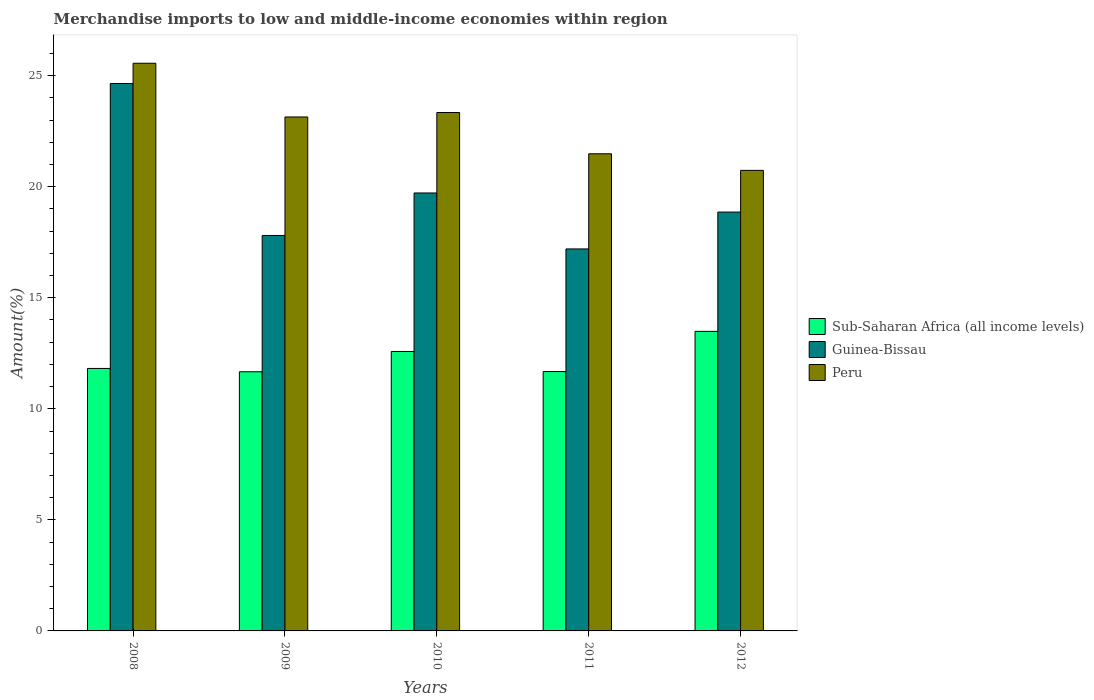Are the number of bars on each tick of the X-axis equal?
Your answer should be very brief. Yes. How many bars are there on the 3rd tick from the right?
Your answer should be compact. 3. What is the percentage of amount earned from merchandise imports in Peru in 2008?
Provide a short and direct response. 25.56. Across all years, what is the maximum percentage of amount earned from merchandise imports in Sub-Saharan Africa (all income levels)?
Offer a terse response. 13.49. Across all years, what is the minimum percentage of amount earned from merchandise imports in Sub-Saharan Africa (all income levels)?
Keep it short and to the point. 11.67. In which year was the percentage of amount earned from merchandise imports in Peru maximum?
Offer a terse response. 2008. In which year was the percentage of amount earned from merchandise imports in Guinea-Bissau minimum?
Your answer should be compact. 2011. What is the total percentage of amount earned from merchandise imports in Peru in the graph?
Provide a short and direct response. 114.26. What is the difference between the percentage of amount earned from merchandise imports in Peru in 2008 and that in 2009?
Ensure brevity in your answer.  2.42. What is the difference between the percentage of amount earned from merchandise imports in Sub-Saharan Africa (all income levels) in 2009 and the percentage of amount earned from merchandise imports in Peru in 2012?
Offer a very short reply. -9.07. What is the average percentage of amount earned from merchandise imports in Guinea-Bissau per year?
Make the answer very short. 19.64. In the year 2012, what is the difference between the percentage of amount earned from merchandise imports in Guinea-Bissau and percentage of amount earned from merchandise imports in Sub-Saharan Africa (all income levels)?
Give a very brief answer. 5.37. What is the ratio of the percentage of amount earned from merchandise imports in Guinea-Bissau in 2009 to that in 2012?
Your answer should be very brief. 0.94. Is the difference between the percentage of amount earned from merchandise imports in Guinea-Bissau in 2008 and 2012 greater than the difference between the percentage of amount earned from merchandise imports in Sub-Saharan Africa (all income levels) in 2008 and 2012?
Provide a succinct answer. Yes. What is the difference between the highest and the second highest percentage of amount earned from merchandise imports in Sub-Saharan Africa (all income levels)?
Ensure brevity in your answer.  0.91. What is the difference between the highest and the lowest percentage of amount earned from merchandise imports in Guinea-Bissau?
Your answer should be very brief. 7.45. In how many years, is the percentage of amount earned from merchandise imports in Guinea-Bissau greater than the average percentage of amount earned from merchandise imports in Guinea-Bissau taken over all years?
Provide a succinct answer. 2. What does the 1st bar from the left in 2010 represents?
Your answer should be very brief. Sub-Saharan Africa (all income levels). What does the 1st bar from the right in 2009 represents?
Offer a very short reply. Peru. Is it the case that in every year, the sum of the percentage of amount earned from merchandise imports in Sub-Saharan Africa (all income levels) and percentage of amount earned from merchandise imports in Guinea-Bissau is greater than the percentage of amount earned from merchandise imports in Peru?
Offer a very short reply. Yes. How many bars are there?
Your response must be concise. 15. How many years are there in the graph?
Offer a terse response. 5. Are the values on the major ticks of Y-axis written in scientific E-notation?
Provide a short and direct response. No. Does the graph contain grids?
Your answer should be compact. No. How many legend labels are there?
Your answer should be compact. 3. How are the legend labels stacked?
Your answer should be compact. Vertical. What is the title of the graph?
Your response must be concise. Merchandise imports to low and middle-income economies within region. Does "Trinidad and Tobago" appear as one of the legend labels in the graph?
Your answer should be very brief. No. What is the label or title of the Y-axis?
Your answer should be very brief. Amount(%). What is the Amount(%) of Sub-Saharan Africa (all income levels) in 2008?
Offer a terse response. 11.82. What is the Amount(%) in Guinea-Bissau in 2008?
Your answer should be compact. 24.65. What is the Amount(%) in Peru in 2008?
Ensure brevity in your answer.  25.56. What is the Amount(%) in Sub-Saharan Africa (all income levels) in 2009?
Offer a terse response. 11.67. What is the Amount(%) in Guinea-Bissau in 2009?
Your answer should be compact. 17.8. What is the Amount(%) of Peru in 2009?
Offer a terse response. 23.14. What is the Amount(%) in Sub-Saharan Africa (all income levels) in 2010?
Your answer should be compact. 12.58. What is the Amount(%) in Guinea-Bissau in 2010?
Your answer should be compact. 19.72. What is the Amount(%) in Peru in 2010?
Your response must be concise. 23.34. What is the Amount(%) in Sub-Saharan Africa (all income levels) in 2011?
Provide a short and direct response. 11.68. What is the Amount(%) in Guinea-Bissau in 2011?
Your answer should be very brief. 17.2. What is the Amount(%) in Peru in 2011?
Offer a terse response. 21.48. What is the Amount(%) of Sub-Saharan Africa (all income levels) in 2012?
Your response must be concise. 13.49. What is the Amount(%) in Guinea-Bissau in 2012?
Offer a very short reply. 18.86. What is the Amount(%) in Peru in 2012?
Your answer should be compact. 20.74. Across all years, what is the maximum Amount(%) in Sub-Saharan Africa (all income levels)?
Ensure brevity in your answer.  13.49. Across all years, what is the maximum Amount(%) of Guinea-Bissau?
Give a very brief answer. 24.65. Across all years, what is the maximum Amount(%) in Peru?
Your answer should be very brief. 25.56. Across all years, what is the minimum Amount(%) of Sub-Saharan Africa (all income levels)?
Your answer should be very brief. 11.67. Across all years, what is the minimum Amount(%) of Guinea-Bissau?
Make the answer very short. 17.2. Across all years, what is the minimum Amount(%) in Peru?
Offer a terse response. 20.74. What is the total Amount(%) in Sub-Saharan Africa (all income levels) in the graph?
Ensure brevity in your answer.  61.23. What is the total Amount(%) in Guinea-Bissau in the graph?
Make the answer very short. 98.22. What is the total Amount(%) of Peru in the graph?
Give a very brief answer. 114.26. What is the difference between the Amount(%) of Sub-Saharan Africa (all income levels) in 2008 and that in 2009?
Your answer should be very brief. 0.15. What is the difference between the Amount(%) of Guinea-Bissau in 2008 and that in 2009?
Ensure brevity in your answer.  6.84. What is the difference between the Amount(%) of Peru in 2008 and that in 2009?
Your answer should be very brief. 2.42. What is the difference between the Amount(%) of Sub-Saharan Africa (all income levels) in 2008 and that in 2010?
Offer a very short reply. -0.76. What is the difference between the Amount(%) of Guinea-Bissau in 2008 and that in 2010?
Make the answer very short. 4.93. What is the difference between the Amount(%) of Peru in 2008 and that in 2010?
Provide a succinct answer. 2.22. What is the difference between the Amount(%) in Sub-Saharan Africa (all income levels) in 2008 and that in 2011?
Provide a short and direct response. 0.14. What is the difference between the Amount(%) in Guinea-Bissau in 2008 and that in 2011?
Your answer should be compact. 7.45. What is the difference between the Amount(%) in Peru in 2008 and that in 2011?
Your answer should be compact. 4.08. What is the difference between the Amount(%) of Sub-Saharan Africa (all income levels) in 2008 and that in 2012?
Provide a succinct answer. -1.67. What is the difference between the Amount(%) in Guinea-Bissau in 2008 and that in 2012?
Offer a very short reply. 5.79. What is the difference between the Amount(%) of Peru in 2008 and that in 2012?
Offer a terse response. 4.82. What is the difference between the Amount(%) of Sub-Saharan Africa (all income levels) in 2009 and that in 2010?
Offer a very short reply. -0.91. What is the difference between the Amount(%) of Guinea-Bissau in 2009 and that in 2010?
Your answer should be very brief. -1.91. What is the difference between the Amount(%) in Peru in 2009 and that in 2010?
Ensure brevity in your answer.  -0.2. What is the difference between the Amount(%) in Sub-Saharan Africa (all income levels) in 2009 and that in 2011?
Provide a short and direct response. -0.01. What is the difference between the Amount(%) of Guinea-Bissau in 2009 and that in 2011?
Provide a short and direct response. 0.61. What is the difference between the Amount(%) of Peru in 2009 and that in 2011?
Make the answer very short. 1.66. What is the difference between the Amount(%) in Sub-Saharan Africa (all income levels) in 2009 and that in 2012?
Give a very brief answer. -1.82. What is the difference between the Amount(%) of Guinea-Bissau in 2009 and that in 2012?
Give a very brief answer. -1.05. What is the difference between the Amount(%) of Peru in 2009 and that in 2012?
Your answer should be compact. 2.4. What is the difference between the Amount(%) in Sub-Saharan Africa (all income levels) in 2010 and that in 2011?
Offer a terse response. 0.9. What is the difference between the Amount(%) of Guinea-Bissau in 2010 and that in 2011?
Make the answer very short. 2.52. What is the difference between the Amount(%) of Peru in 2010 and that in 2011?
Provide a short and direct response. 1.86. What is the difference between the Amount(%) in Sub-Saharan Africa (all income levels) in 2010 and that in 2012?
Your response must be concise. -0.91. What is the difference between the Amount(%) of Guinea-Bissau in 2010 and that in 2012?
Provide a short and direct response. 0.86. What is the difference between the Amount(%) in Peru in 2010 and that in 2012?
Make the answer very short. 2.61. What is the difference between the Amount(%) in Sub-Saharan Africa (all income levels) in 2011 and that in 2012?
Give a very brief answer. -1.81. What is the difference between the Amount(%) in Guinea-Bissau in 2011 and that in 2012?
Offer a very short reply. -1.66. What is the difference between the Amount(%) in Peru in 2011 and that in 2012?
Ensure brevity in your answer.  0.75. What is the difference between the Amount(%) of Sub-Saharan Africa (all income levels) in 2008 and the Amount(%) of Guinea-Bissau in 2009?
Ensure brevity in your answer.  -5.99. What is the difference between the Amount(%) in Sub-Saharan Africa (all income levels) in 2008 and the Amount(%) in Peru in 2009?
Your answer should be compact. -11.32. What is the difference between the Amount(%) of Guinea-Bissau in 2008 and the Amount(%) of Peru in 2009?
Your response must be concise. 1.51. What is the difference between the Amount(%) in Sub-Saharan Africa (all income levels) in 2008 and the Amount(%) in Guinea-Bissau in 2010?
Provide a succinct answer. -7.9. What is the difference between the Amount(%) of Sub-Saharan Africa (all income levels) in 2008 and the Amount(%) of Peru in 2010?
Your answer should be very brief. -11.52. What is the difference between the Amount(%) of Guinea-Bissau in 2008 and the Amount(%) of Peru in 2010?
Offer a very short reply. 1.31. What is the difference between the Amount(%) in Sub-Saharan Africa (all income levels) in 2008 and the Amount(%) in Guinea-Bissau in 2011?
Provide a succinct answer. -5.38. What is the difference between the Amount(%) of Sub-Saharan Africa (all income levels) in 2008 and the Amount(%) of Peru in 2011?
Provide a short and direct response. -9.67. What is the difference between the Amount(%) in Guinea-Bissau in 2008 and the Amount(%) in Peru in 2011?
Your answer should be very brief. 3.16. What is the difference between the Amount(%) in Sub-Saharan Africa (all income levels) in 2008 and the Amount(%) in Guinea-Bissau in 2012?
Your answer should be very brief. -7.04. What is the difference between the Amount(%) in Sub-Saharan Africa (all income levels) in 2008 and the Amount(%) in Peru in 2012?
Your answer should be very brief. -8.92. What is the difference between the Amount(%) of Guinea-Bissau in 2008 and the Amount(%) of Peru in 2012?
Your answer should be compact. 3.91. What is the difference between the Amount(%) of Sub-Saharan Africa (all income levels) in 2009 and the Amount(%) of Guinea-Bissau in 2010?
Ensure brevity in your answer.  -8.05. What is the difference between the Amount(%) in Sub-Saharan Africa (all income levels) in 2009 and the Amount(%) in Peru in 2010?
Provide a short and direct response. -11.67. What is the difference between the Amount(%) in Guinea-Bissau in 2009 and the Amount(%) in Peru in 2010?
Your answer should be compact. -5.54. What is the difference between the Amount(%) of Sub-Saharan Africa (all income levels) in 2009 and the Amount(%) of Guinea-Bissau in 2011?
Make the answer very short. -5.53. What is the difference between the Amount(%) of Sub-Saharan Africa (all income levels) in 2009 and the Amount(%) of Peru in 2011?
Provide a succinct answer. -9.81. What is the difference between the Amount(%) in Guinea-Bissau in 2009 and the Amount(%) in Peru in 2011?
Your answer should be compact. -3.68. What is the difference between the Amount(%) in Sub-Saharan Africa (all income levels) in 2009 and the Amount(%) in Guinea-Bissau in 2012?
Your answer should be compact. -7.19. What is the difference between the Amount(%) in Sub-Saharan Africa (all income levels) in 2009 and the Amount(%) in Peru in 2012?
Make the answer very short. -9.07. What is the difference between the Amount(%) in Guinea-Bissau in 2009 and the Amount(%) in Peru in 2012?
Give a very brief answer. -2.93. What is the difference between the Amount(%) in Sub-Saharan Africa (all income levels) in 2010 and the Amount(%) in Guinea-Bissau in 2011?
Keep it short and to the point. -4.62. What is the difference between the Amount(%) of Sub-Saharan Africa (all income levels) in 2010 and the Amount(%) of Peru in 2011?
Keep it short and to the point. -8.9. What is the difference between the Amount(%) in Guinea-Bissau in 2010 and the Amount(%) in Peru in 2011?
Provide a succinct answer. -1.76. What is the difference between the Amount(%) of Sub-Saharan Africa (all income levels) in 2010 and the Amount(%) of Guinea-Bissau in 2012?
Make the answer very short. -6.28. What is the difference between the Amount(%) in Sub-Saharan Africa (all income levels) in 2010 and the Amount(%) in Peru in 2012?
Provide a succinct answer. -8.15. What is the difference between the Amount(%) in Guinea-Bissau in 2010 and the Amount(%) in Peru in 2012?
Offer a terse response. -1.02. What is the difference between the Amount(%) in Sub-Saharan Africa (all income levels) in 2011 and the Amount(%) in Guinea-Bissau in 2012?
Ensure brevity in your answer.  -7.18. What is the difference between the Amount(%) in Sub-Saharan Africa (all income levels) in 2011 and the Amount(%) in Peru in 2012?
Provide a short and direct response. -9.06. What is the difference between the Amount(%) in Guinea-Bissau in 2011 and the Amount(%) in Peru in 2012?
Offer a very short reply. -3.54. What is the average Amount(%) in Sub-Saharan Africa (all income levels) per year?
Provide a short and direct response. 12.25. What is the average Amount(%) of Guinea-Bissau per year?
Your answer should be compact. 19.64. What is the average Amount(%) in Peru per year?
Your answer should be compact. 22.85. In the year 2008, what is the difference between the Amount(%) of Sub-Saharan Africa (all income levels) and Amount(%) of Guinea-Bissau?
Make the answer very short. -12.83. In the year 2008, what is the difference between the Amount(%) of Sub-Saharan Africa (all income levels) and Amount(%) of Peru?
Ensure brevity in your answer.  -13.74. In the year 2008, what is the difference between the Amount(%) in Guinea-Bissau and Amount(%) in Peru?
Your response must be concise. -0.91. In the year 2009, what is the difference between the Amount(%) of Sub-Saharan Africa (all income levels) and Amount(%) of Guinea-Bissau?
Make the answer very short. -6.14. In the year 2009, what is the difference between the Amount(%) in Sub-Saharan Africa (all income levels) and Amount(%) in Peru?
Your answer should be compact. -11.47. In the year 2009, what is the difference between the Amount(%) in Guinea-Bissau and Amount(%) in Peru?
Give a very brief answer. -5.34. In the year 2010, what is the difference between the Amount(%) in Sub-Saharan Africa (all income levels) and Amount(%) in Guinea-Bissau?
Keep it short and to the point. -7.14. In the year 2010, what is the difference between the Amount(%) in Sub-Saharan Africa (all income levels) and Amount(%) in Peru?
Offer a terse response. -10.76. In the year 2010, what is the difference between the Amount(%) of Guinea-Bissau and Amount(%) of Peru?
Give a very brief answer. -3.62. In the year 2011, what is the difference between the Amount(%) of Sub-Saharan Africa (all income levels) and Amount(%) of Guinea-Bissau?
Offer a terse response. -5.52. In the year 2011, what is the difference between the Amount(%) in Sub-Saharan Africa (all income levels) and Amount(%) in Peru?
Keep it short and to the point. -9.81. In the year 2011, what is the difference between the Amount(%) of Guinea-Bissau and Amount(%) of Peru?
Provide a succinct answer. -4.28. In the year 2012, what is the difference between the Amount(%) in Sub-Saharan Africa (all income levels) and Amount(%) in Guinea-Bissau?
Offer a very short reply. -5.37. In the year 2012, what is the difference between the Amount(%) in Sub-Saharan Africa (all income levels) and Amount(%) in Peru?
Offer a very short reply. -7.25. In the year 2012, what is the difference between the Amount(%) of Guinea-Bissau and Amount(%) of Peru?
Offer a very short reply. -1.88. What is the ratio of the Amount(%) in Sub-Saharan Africa (all income levels) in 2008 to that in 2009?
Ensure brevity in your answer.  1.01. What is the ratio of the Amount(%) in Guinea-Bissau in 2008 to that in 2009?
Make the answer very short. 1.38. What is the ratio of the Amount(%) in Peru in 2008 to that in 2009?
Your answer should be very brief. 1.1. What is the ratio of the Amount(%) in Sub-Saharan Africa (all income levels) in 2008 to that in 2010?
Your answer should be compact. 0.94. What is the ratio of the Amount(%) in Guinea-Bissau in 2008 to that in 2010?
Keep it short and to the point. 1.25. What is the ratio of the Amount(%) of Peru in 2008 to that in 2010?
Keep it short and to the point. 1.09. What is the ratio of the Amount(%) in Guinea-Bissau in 2008 to that in 2011?
Offer a terse response. 1.43. What is the ratio of the Amount(%) in Peru in 2008 to that in 2011?
Your response must be concise. 1.19. What is the ratio of the Amount(%) of Sub-Saharan Africa (all income levels) in 2008 to that in 2012?
Your answer should be compact. 0.88. What is the ratio of the Amount(%) in Guinea-Bissau in 2008 to that in 2012?
Ensure brevity in your answer.  1.31. What is the ratio of the Amount(%) in Peru in 2008 to that in 2012?
Offer a terse response. 1.23. What is the ratio of the Amount(%) in Sub-Saharan Africa (all income levels) in 2009 to that in 2010?
Your response must be concise. 0.93. What is the ratio of the Amount(%) in Guinea-Bissau in 2009 to that in 2010?
Your answer should be very brief. 0.9. What is the ratio of the Amount(%) in Sub-Saharan Africa (all income levels) in 2009 to that in 2011?
Ensure brevity in your answer.  1. What is the ratio of the Amount(%) in Guinea-Bissau in 2009 to that in 2011?
Your answer should be compact. 1.04. What is the ratio of the Amount(%) in Peru in 2009 to that in 2011?
Offer a terse response. 1.08. What is the ratio of the Amount(%) of Sub-Saharan Africa (all income levels) in 2009 to that in 2012?
Give a very brief answer. 0.87. What is the ratio of the Amount(%) of Guinea-Bissau in 2009 to that in 2012?
Your answer should be compact. 0.94. What is the ratio of the Amount(%) in Peru in 2009 to that in 2012?
Provide a succinct answer. 1.12. What is the ratio of the Amount(%) of Sub-Saharan Africa (all income levels) in 2010 to that in 2011?
Give a very brief answer. 1.08. What is the ratio of the Amount(%) in Guinea-Bissau in 2010 to that in 2011?
Provide a succinct answer. 1.15. What is the ratio of the Amount(%) of Peru in 2010 to that in 2011?
Offer a terse response. 1.09. What is the ratio of the Amount(%) in Sub-Saharan Africa (all income levels) in 2010 to that in 2012?
Offer a terse response. 0.93. What is the ratio of the Amount(%) of Guinea-Bissau in 2010 to that in 2012?
Keep it short and to the point. 1.05. What is the ratio of the Amount(%) in Peru in 2010 to that in 2012?
Your answer should be compact. 1.13. What is the ratio of the Amount(%) in Sub-Saharan Africa (all income levels) in 2011 to that in 2012?
Provide a succinct answer. 0.87. What is the ratio of the Amount(%) of Guinea-Bissau in 2011 to that in 2012?
Provide a succinct answer. 0.91. What is the ratio of the Amount(%) in Peru in 2011 to that in 2012?
Offer a terse response. 1.04. What is the difference between the highest and the second highest Amount(%) in Sub-Saharan Africa (all income levels)?
Your response must be concise. 0.91. What is the difference between the highest and the second highest Amount(%) of Guinea-Bissau?
Keep it short and to the point. 4.93. What is the difference between the highest and the second highest Amount(%) in Peru?
Give a very brief answer. 2.22. What is the difference between the highest and the lowest Amount(%) in Sub-Saharan Africa (all income levels)?
Give a very brief answer. 1.82. What is the difference between the highest and the lowest Amount(%) of Guinea-Bissau?
Keep it short and to the point. 7.45. What is the difference between the highest and the lowest Amount(%) of Peru?
Make the answer very short. 4.82. 